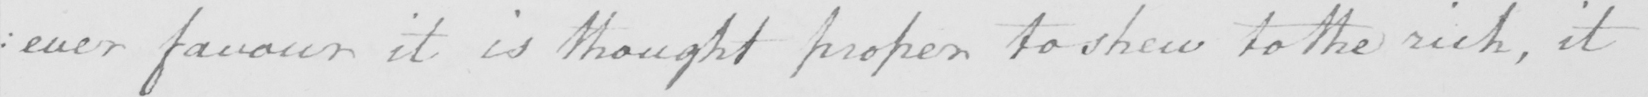Can you tell me what this handwritten text says? :  ever favour it is thought proper to shew to the rich , it 